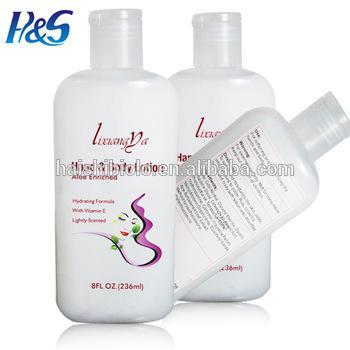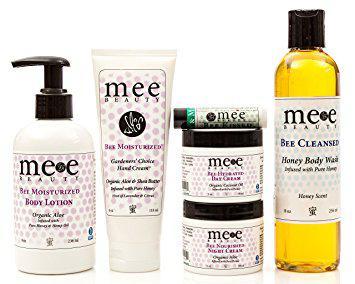The first image is the image on the left, the second image is the image on the right. Considering the images on both sides, is "One image includes an upright bottle with a black pump-top near a tube displayed upright sitting on its white cap." valid? Answer yes or no. Yes. The first image is the image on the left, the second image is the image on the right. Examine the images to the left and right. Is the description "There are more items in the right image than in the left image." accurate? Answer yes or no. Yes. 